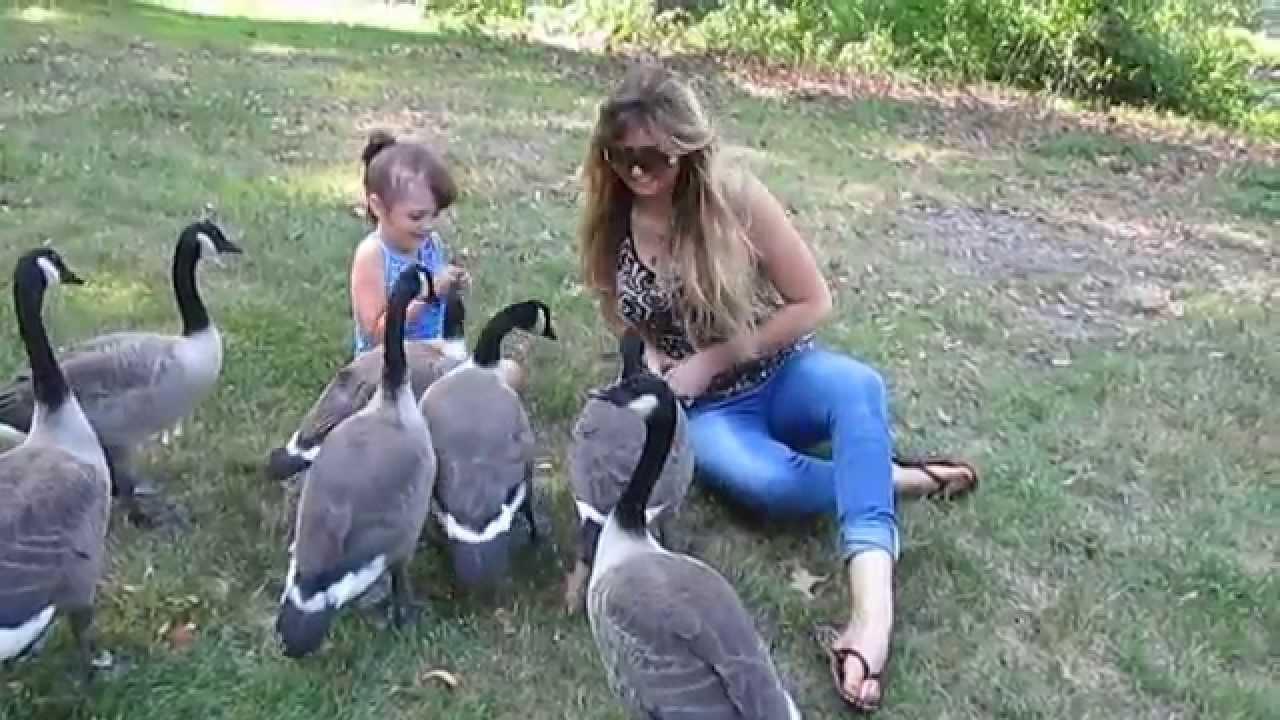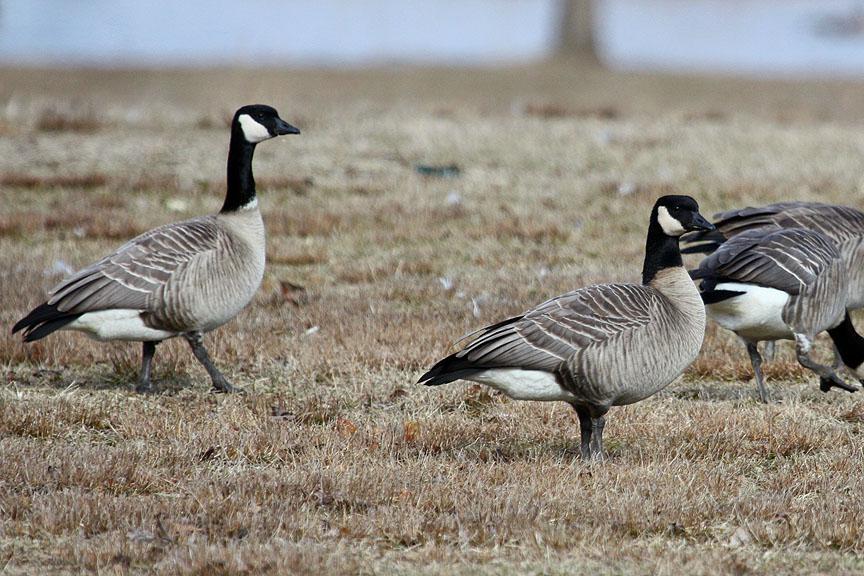The first image is the image on the left, the second image is the image on the right. Considering the images on both sides, is "in at least one image there are geese eating the grass" valid? Answer yes or no. No. The first image is the image on the left, the second image is the image on the right. For the images displayed, is the sentence "One image has water fowl in the water." factually correct? Answer yes or no. No. 